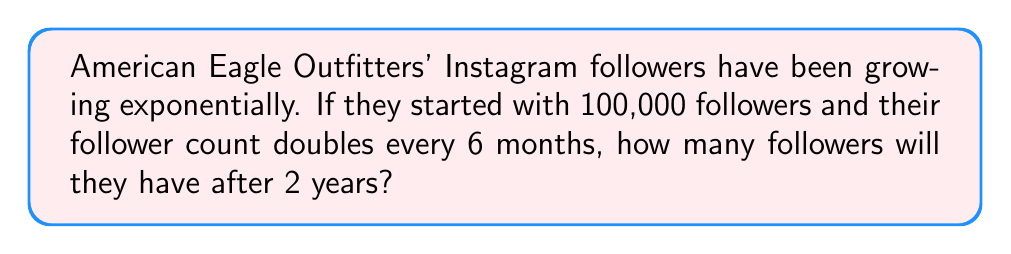Can you solve this math problem? Let's approach this step-by-step:

1) We start with the initial number of followers:
   $N_0 = 100,000$

2) The growth rate is doubling (×2) every 6 months. In 2 years, there are 4 periods of 6 months.

3) We can represent this growth using an exponential function:
   $N(t) = N_0 \cdot 2^t$
   where $t$ is the number of 6-month periods.

4) After 2 years (4 periods), we have:
   $N(4) = 100,000 \cdot 2^4$

5) Let's calculate this:
   $N(4) = 100,000 \cdot 2^4$
   $    = 100,000 \cdot 16$
   $    = 1,600,000$

Therefore, after 2 years, American Eagle Outfitters will have 1,600,000 Instagram followers.
Answer: 1,600,000 followers 